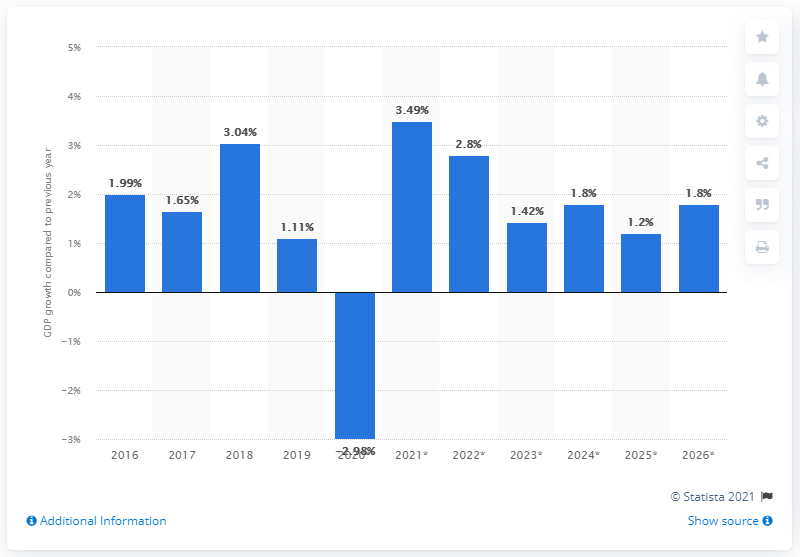Mention a couple of crucial points in this snapshot. According to the information provided, in 2019, the Gross Domestic Product (GDP) of Switzerland increased by 1.11%. 